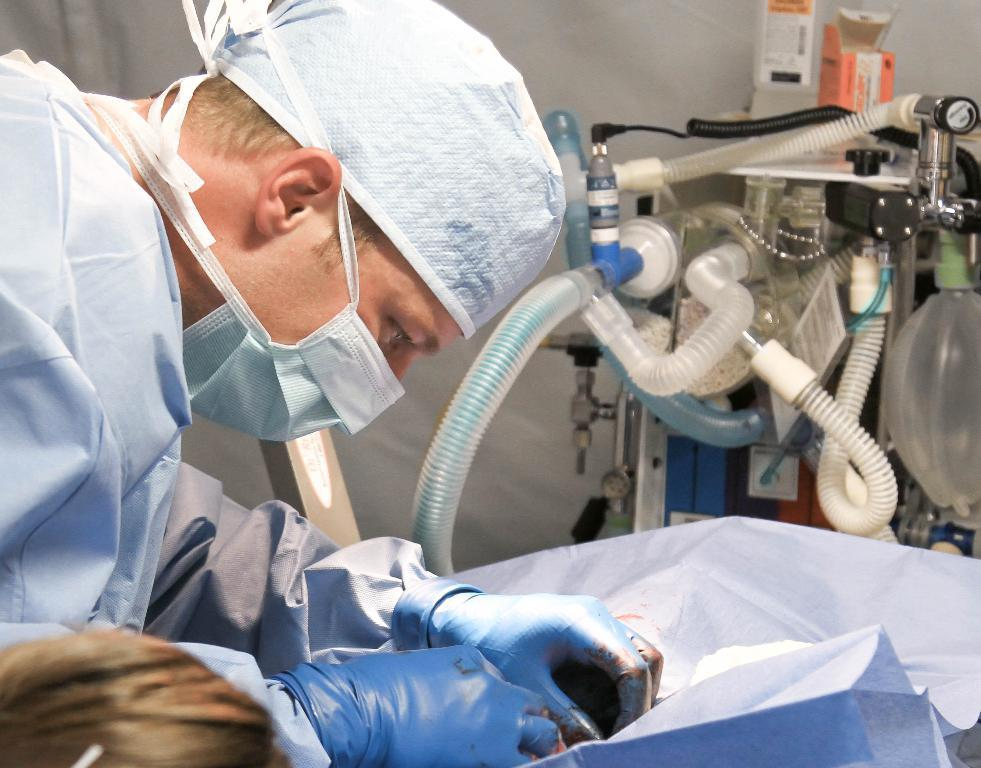What is the person in the image wearing? The person is wearing a mask and apron in the image. What is the person doing in the image? The person is operating a human in the image. What is the purpose of the oxygen cylinder in the image? The oxygen cylinder is present in the image, but its purpose is not explicitly stated. What type of equipment can be seen in the image? There is machinery in the image. What type of covering is present in the image? There is a curtain in the image. What type of experience can be seen on the faces of the bears in the image? There are no bears present in the image; it features a person wearing a mask and apron, operating a human, and surrounded by machinery and an oxygen cylinder. How many ducks are visible in the image? There are no ducks present in the image. 